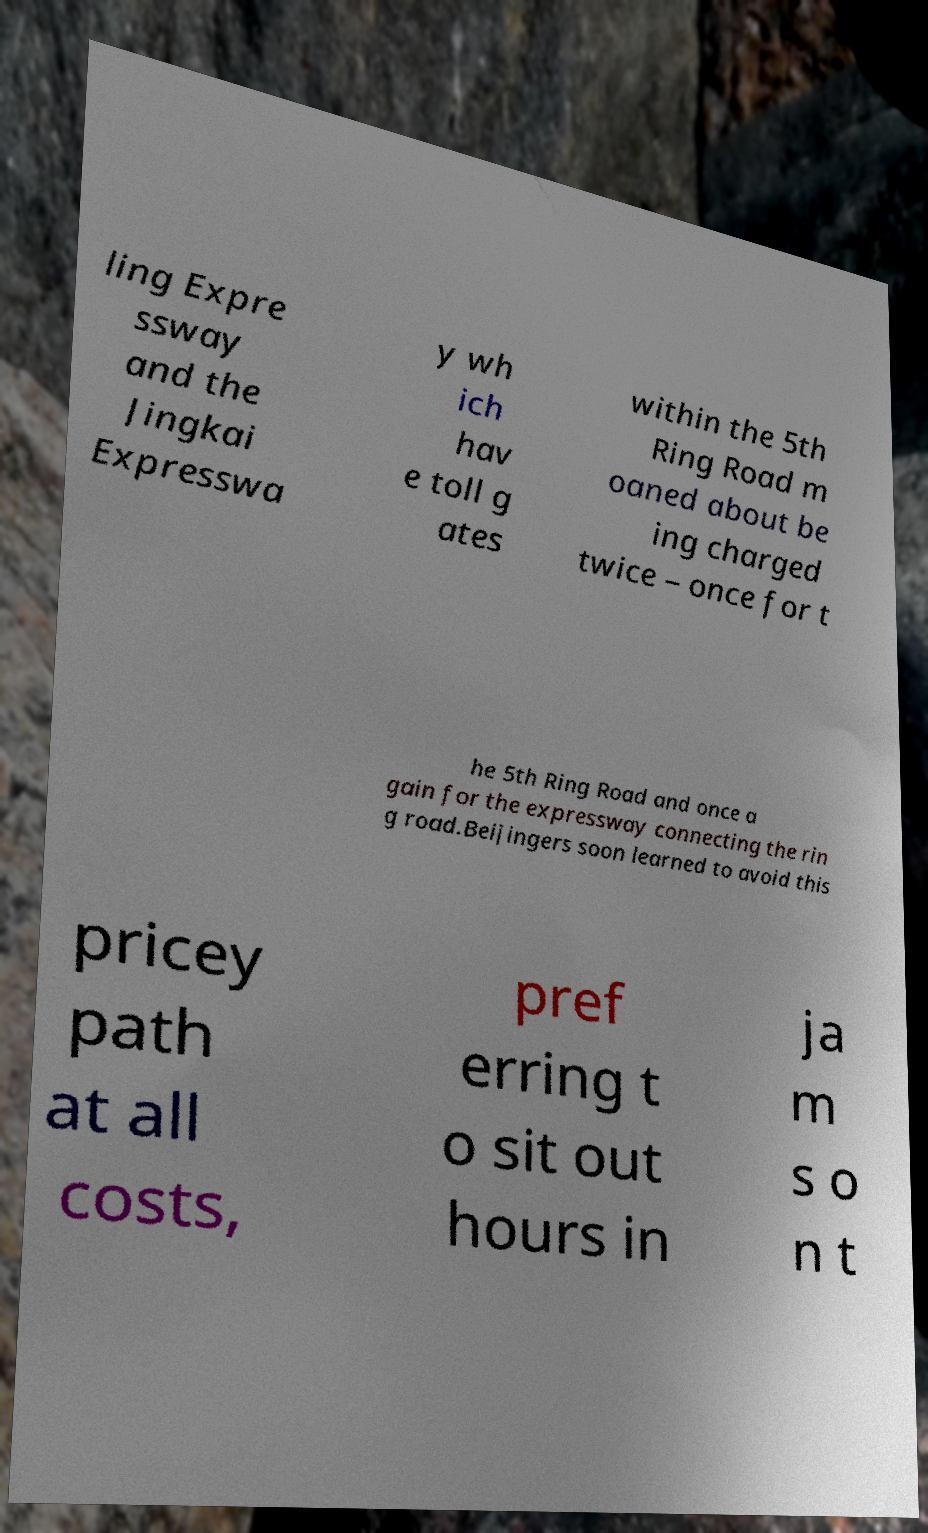Can you accurately transcribe the text from the provided image for me? ling Expre ssway and the Jingkai Expresswa y wh ich hav e toll g ates within the 5th Ring Road m oaned about be ing charged twice – once for t he 5th Ring Road and once a gain for the expressway connecting the rin g road.Beijingers soon learned to avoid this pricey path at all costs, pref erring t o sit out hours in ja m s o n t 